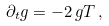Convert formula to latex. <formula><loc_0><loc_0><loc_500><loc_500>\partial _ { t } g = - 2 \, g T \, ,</formula> 